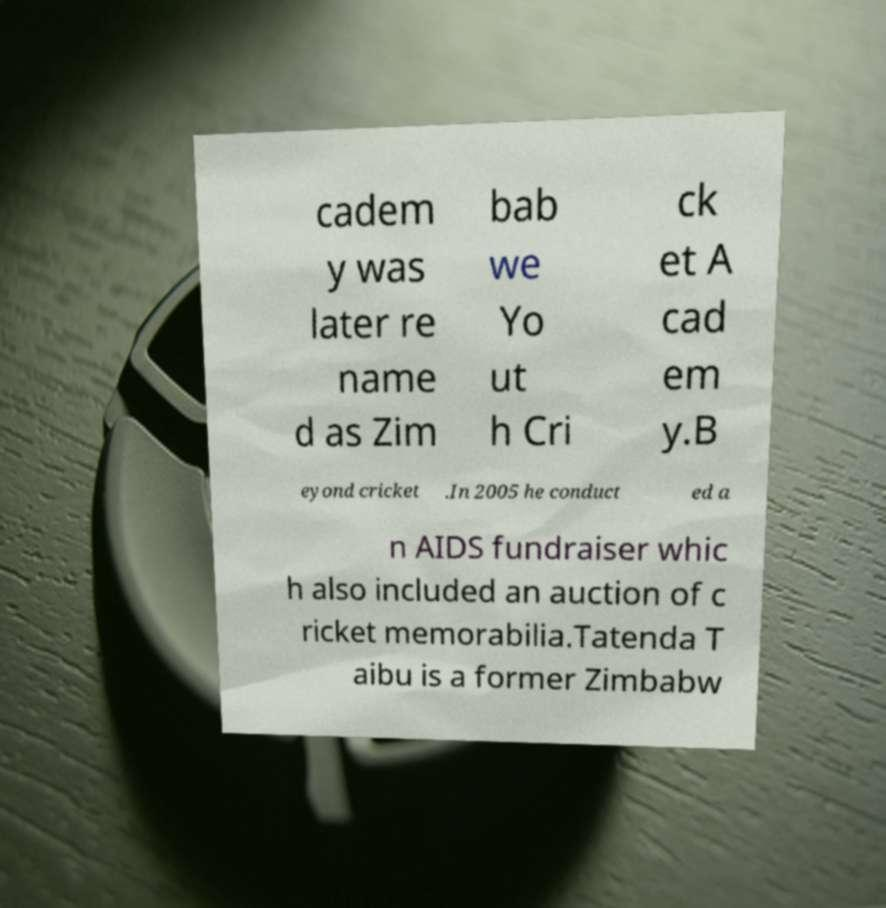What messages or text are displayed in this image? I need them in a readable, typed format. cadem y was later re name d as Zim bab we Yo ut h Cri ck et A cad em y.B eyond cricket .In 2005 he conduct ed a n AIDS fundraiser whic h also included an auction of c ricket memorabilia.Tatenda T aibu is a former Zimbabw 